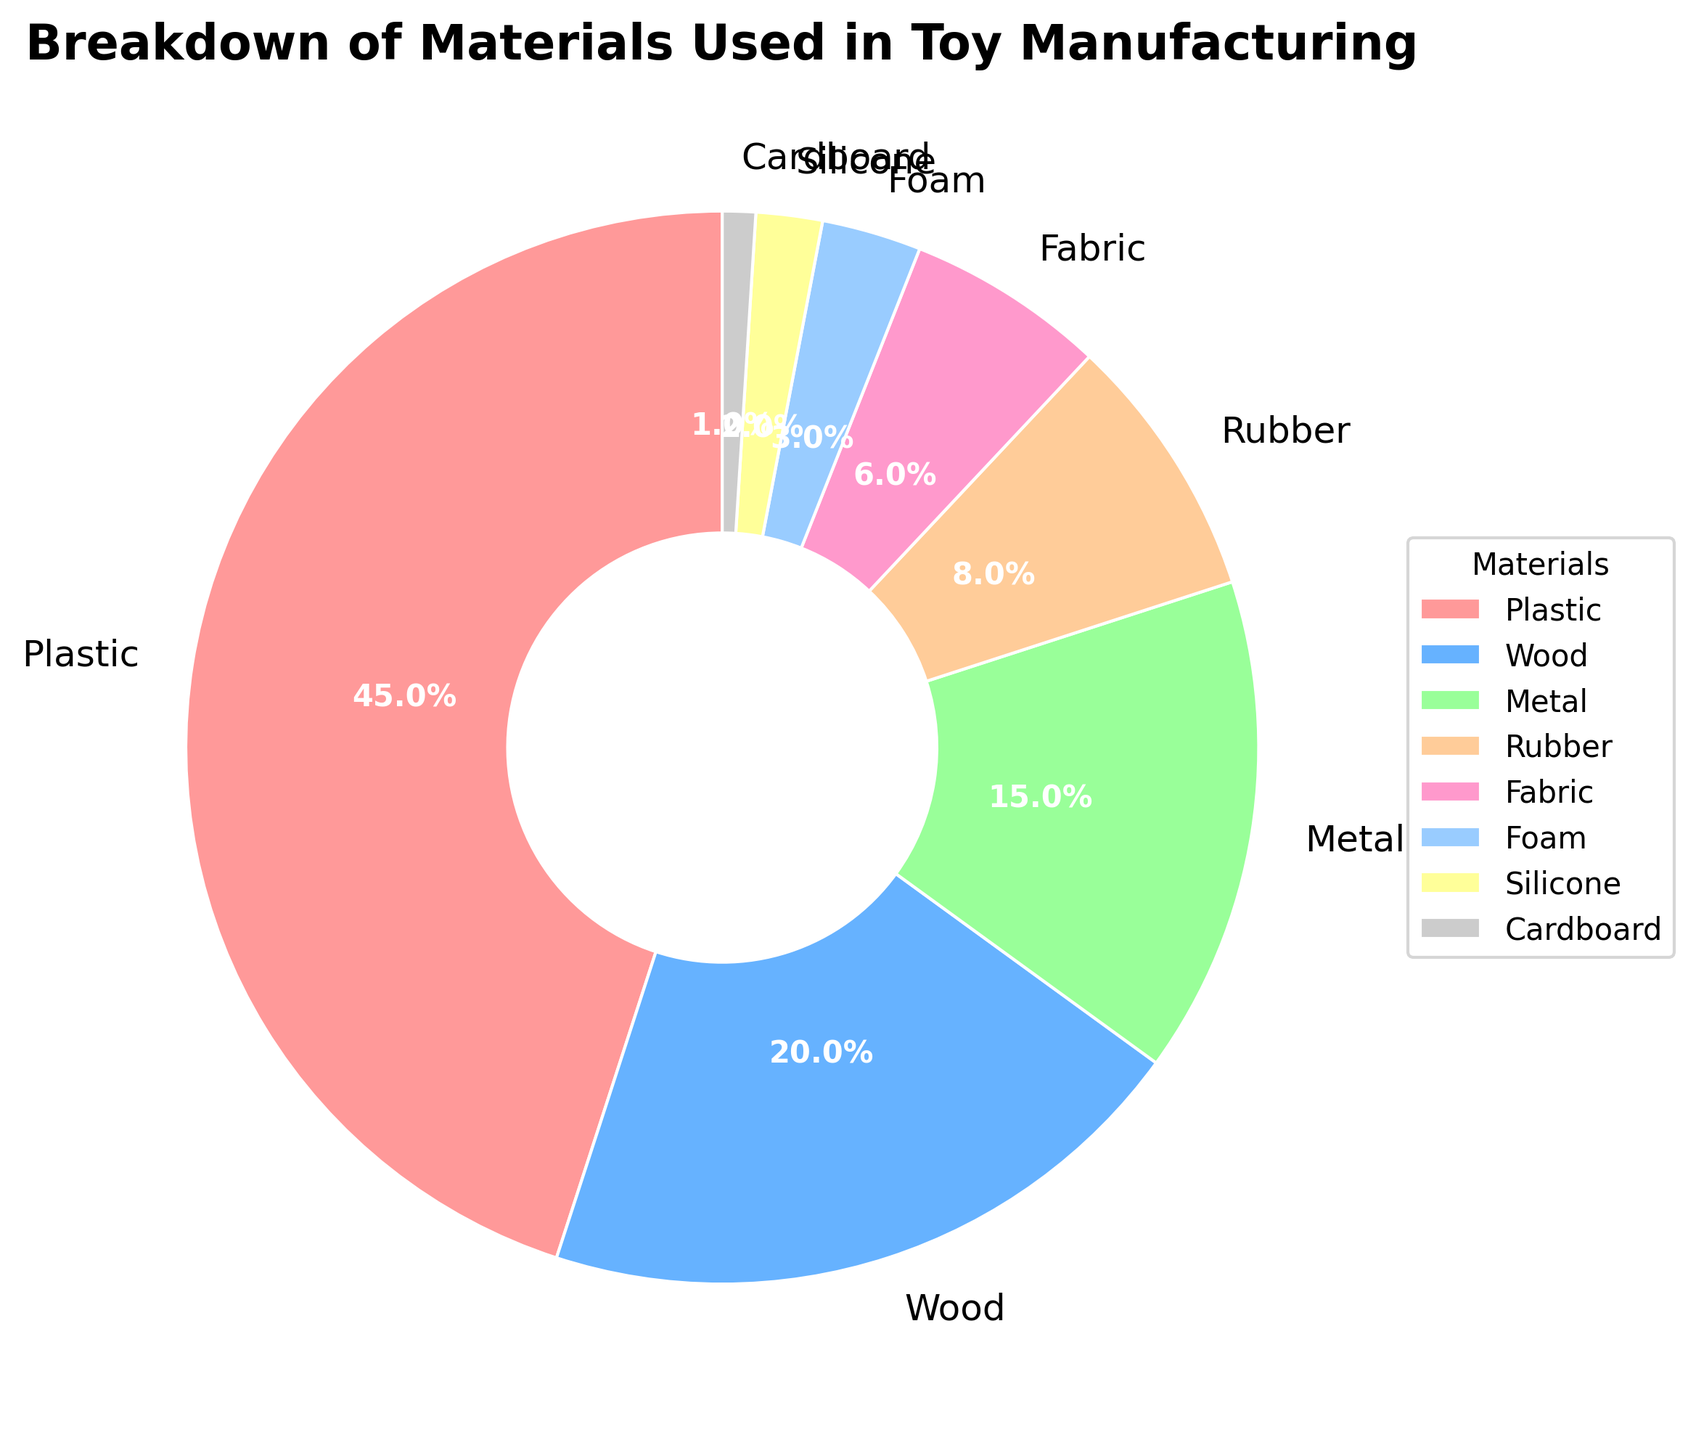What's the material with the highest usage percentage? From the pie chart, the largest segment corresponds to plastic. The label shows it occupies 45% of the total materials used.
Answer: Plastic How much more percentage is plastic used compared to wood? The usage of plastic is 45% while wood is 20%. Subtracting wood's percentage from plastic's gives: 45% - 20% = 25%.
Answer: 25% What's the combined usage percentage of metal and rubber? Metal occupies 15% and rubber occupies 8%. Adding these together: 15% + 8% = 23%.
Answer: 23% Which materials share the smallest percentage of usage and what is their combined percentage? The chart shows foam, silicone, and cardboard have the smallest sections, labeled 3%, 2%, and 1% respectively. Adding these: 3% + 2% + 1% = 6%.
Answer: Foam, silicone, and cardboard, 6% Is the combined usage of fabric and foam greater or lesser than the usage of wood? Fabric is 6% and foam is 3%. Adding these together: 6% + 3% = 9%. Wood is 20%. Since 9% < 20%, the combined usage is lesser.
Answer: Lesser Among wood, metal, and fabric, which material is used the least? Wood is 20%, metal is 15%, and fabric is 6%. The least among these is fabric at 6%.
Answer: Fabric Which material section appears in orange and what is its percentage? By visually inspecting the pie chart, we identify rubber as the orange section. The label indicates it occupies 8%.
Answer: Rubber, 8% What's the difference in usage percentage between the most used and least used material? The plastic section is the largest at 45% and cardboard is the smallest at 1%. Subtracting: 45% - 1% = 44%.
Answer: 44% Compare the usage percentages of rubber and foam. Which is higher and by how much? Rubber is at 8% and foam is at 3%. Subtracting these: 8% - 3% = 5%. Rubber's usage is 5% higher than foam.
Answer: Rubber, 5% higher 